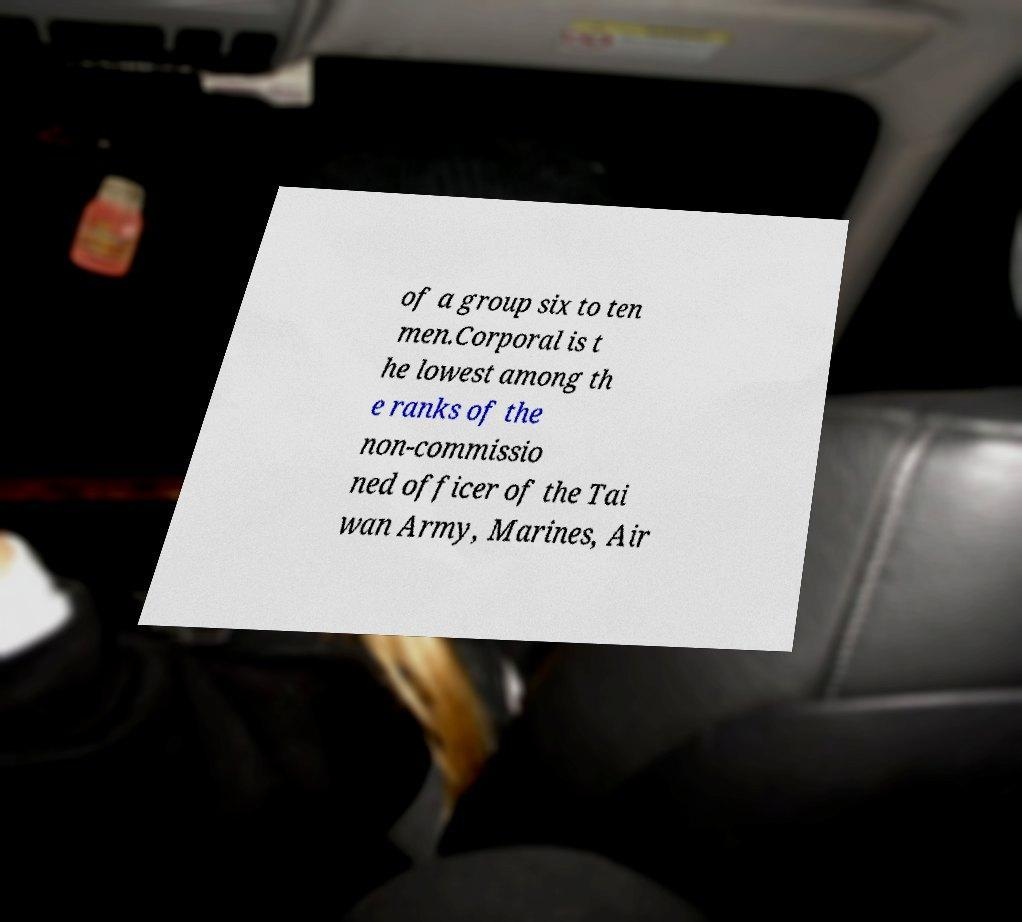Could you assist in decoding the text presented in this image and type it out clearly? of a group six to ten men.Corporal is t he lowest among th e ranks of the non-commissio ned officer of the Tai wan Army, Marines, Air 